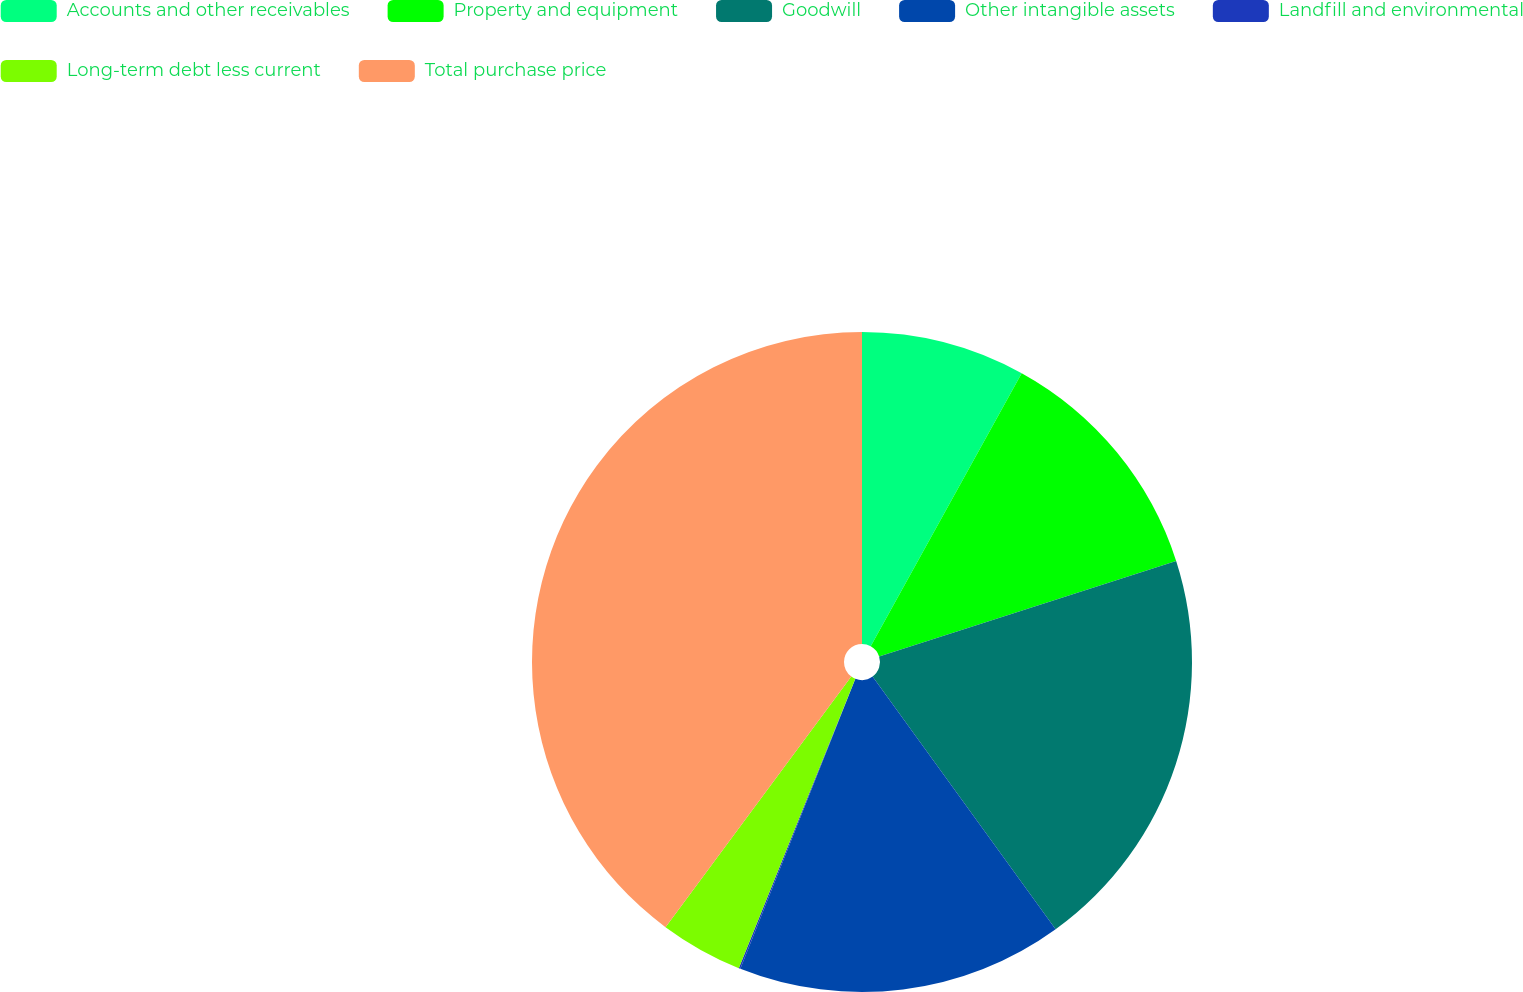Convert chart to OTSL. <chart><loc_0><loc_0><loc_500><loc_500><pie_chart><fcel>Accounts and other receivables<fcel>Property and equipment<fcel>Goodwill<fcel>Other intangible assets<fcel>Landfill and environmental<fcel>Long-term debt less current<fcel>Total purchase price<nl><fcel>8.04%<fcel>12.01%<fcel>19.97%<fcel>15.99%<fcel>0.08%<fcel>4.06%<fcel>39.85%<nl></chart> 